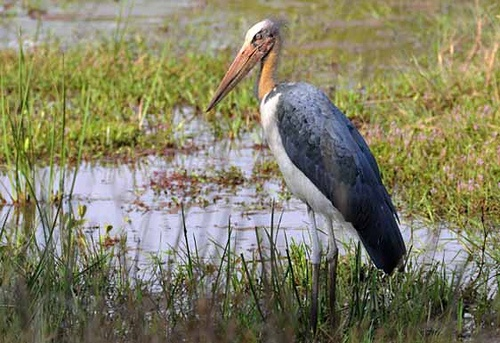Describe the objects in this image and their specific colors. I can see a bird in tan, black, gray, and darkgray tones in this image. 